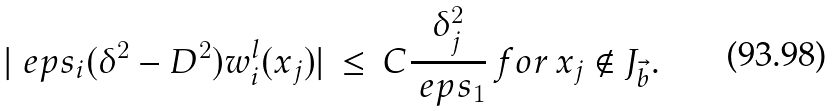Convert formula to latex. <formula><loc_0><loc_0><loc_500><loc_500>| \ e p s _ { i } ( \delta ^ { 2 } - D ^ { 2 } ) w ^ { l } _ { i } ( x _ { j } ) | \, \leq \, C \frac { \delta ^ { 2 } _ { j } } { \ e p s _ { 1 } } \, f o r \, x _ { j } \notin J _ { \vec { b } } .</formula> 